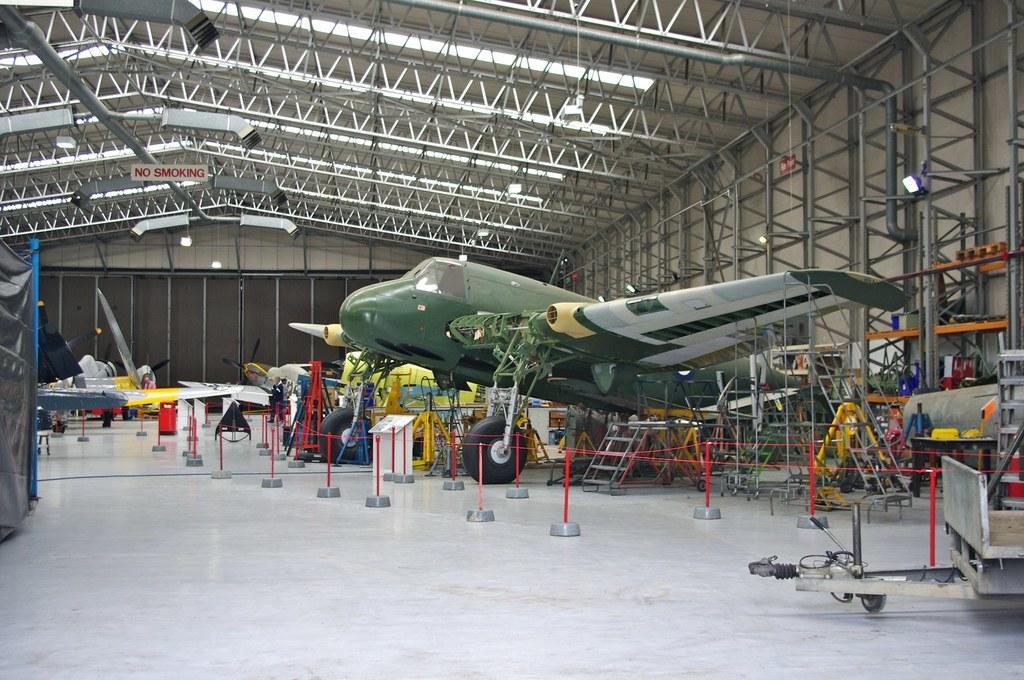<image>
Relay a brief, clear account of the picture shown. An aircraft is on display in a large hangar with a no smoking sign. 